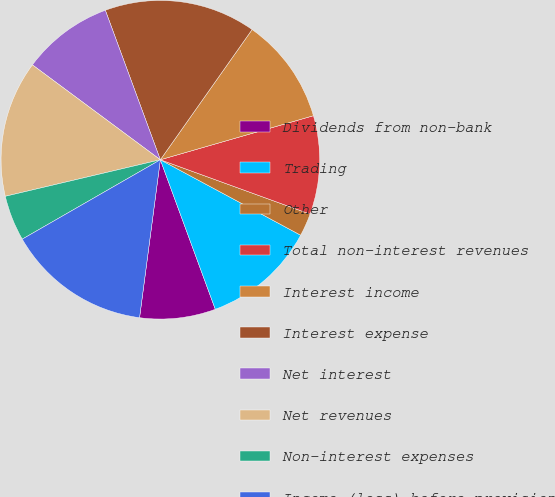Convert chart. <chart><loc_0><loc_0><loc_500><loc_500><pie_chart><fcel>Dividends from non-bank<fcel>Trading<fcel>Other<fcel>Total non-interest revenues<fcel>Interest income<fcel>Interest expense<fcel>Net interest<fcel>Net revenues<fcel>Non-interest expenses<fcel>Income (loss) before provision<nl><fcel>7.69%<fcel>11.54%<fcel>2.31%<fcel>10.0%<fcel>10.77%<fcel>15.38%<fcel>9.23%<fcel>13.84%<fcel>4.62%<fcel>14.61%<nl></chart> 